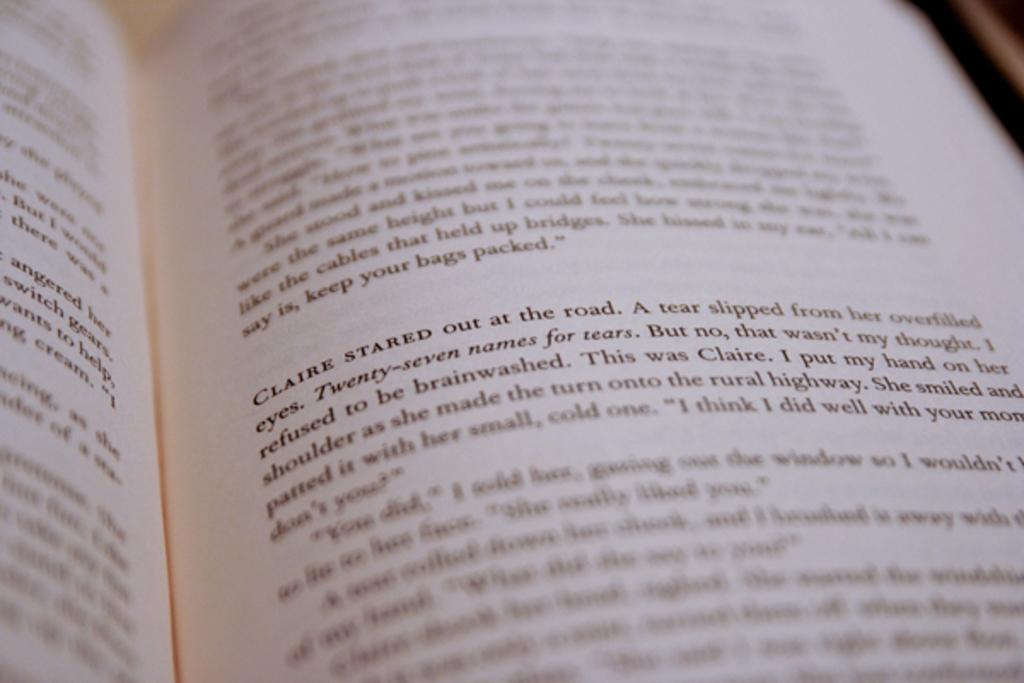Who stared out at the road?
Your answer should be compact. Claire. What is the name of the person in the text?
Your answer should be very brief. Claire. 